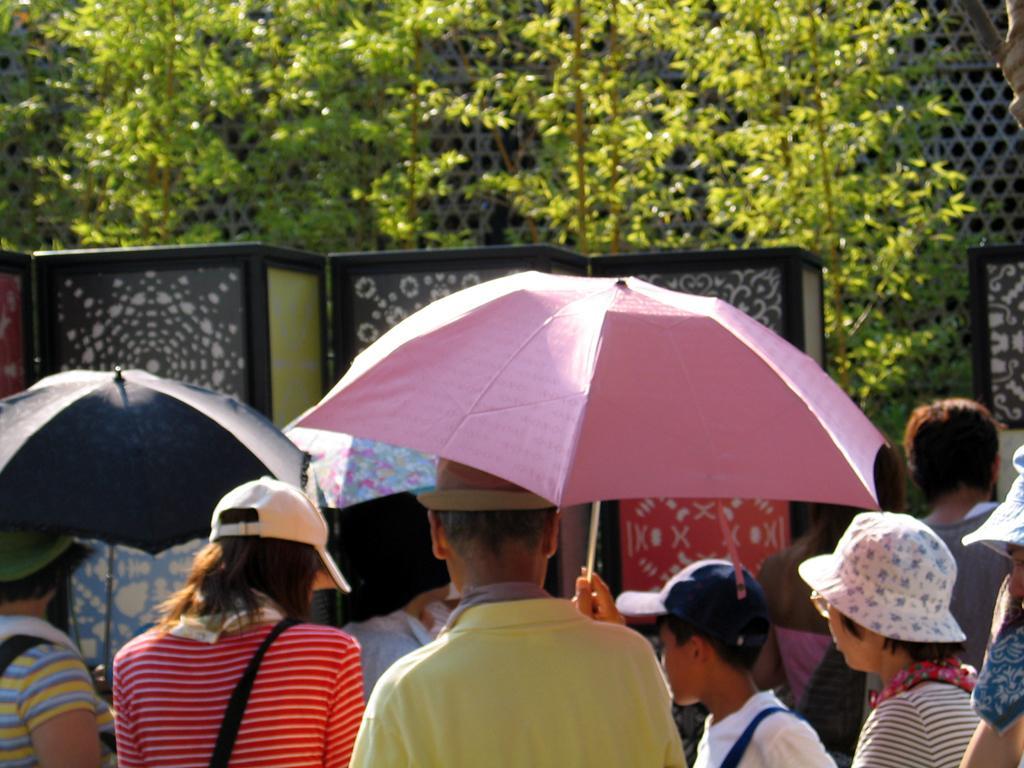Could you give a brief overview of what you see in this image? We can see group of people and umbrellas. On the background we can see mesh and trees. 